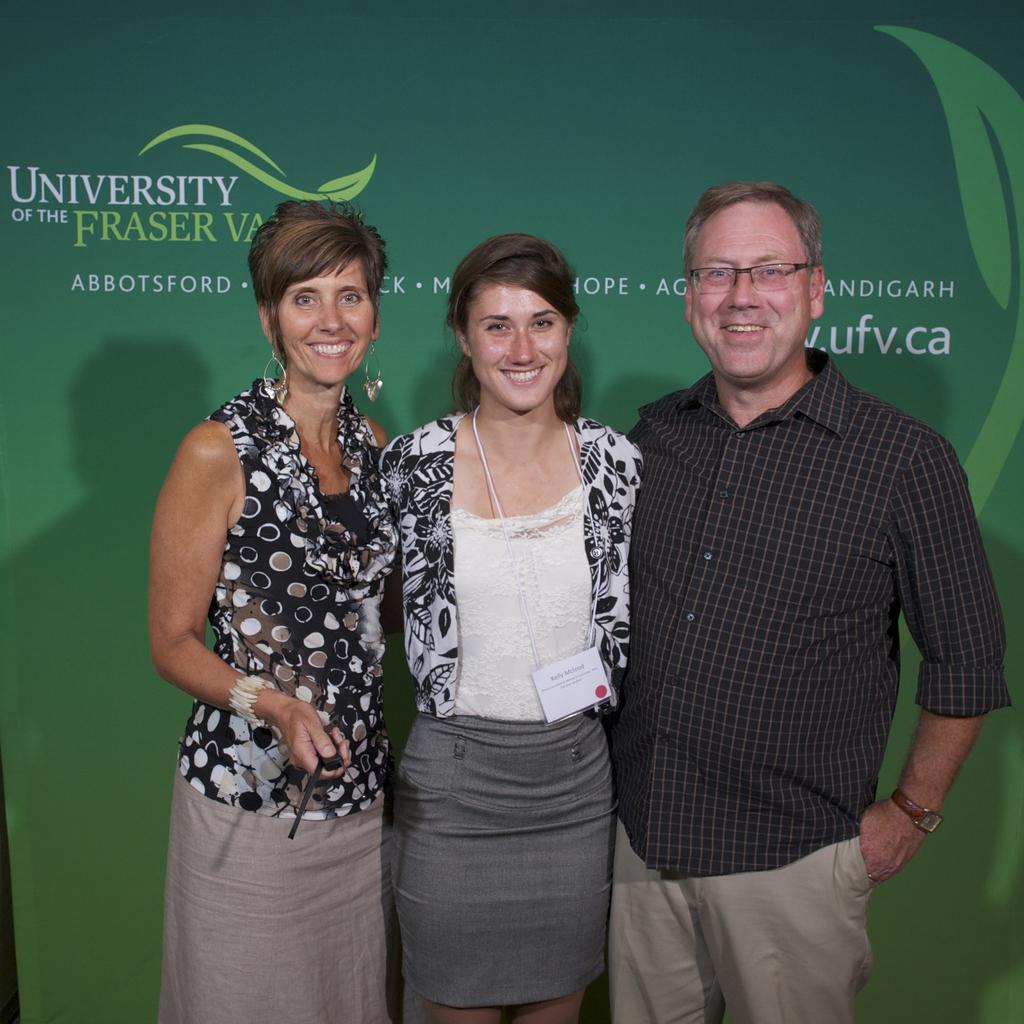Please provide a concise description of this image. In this image we can see a man and two women are standing and smiling. Man is wearing black shirt and cream pant. One woman is wearing white top with grey skirt and the other one is wearing black and white dress. Background green color banner is there with some text written on it. 